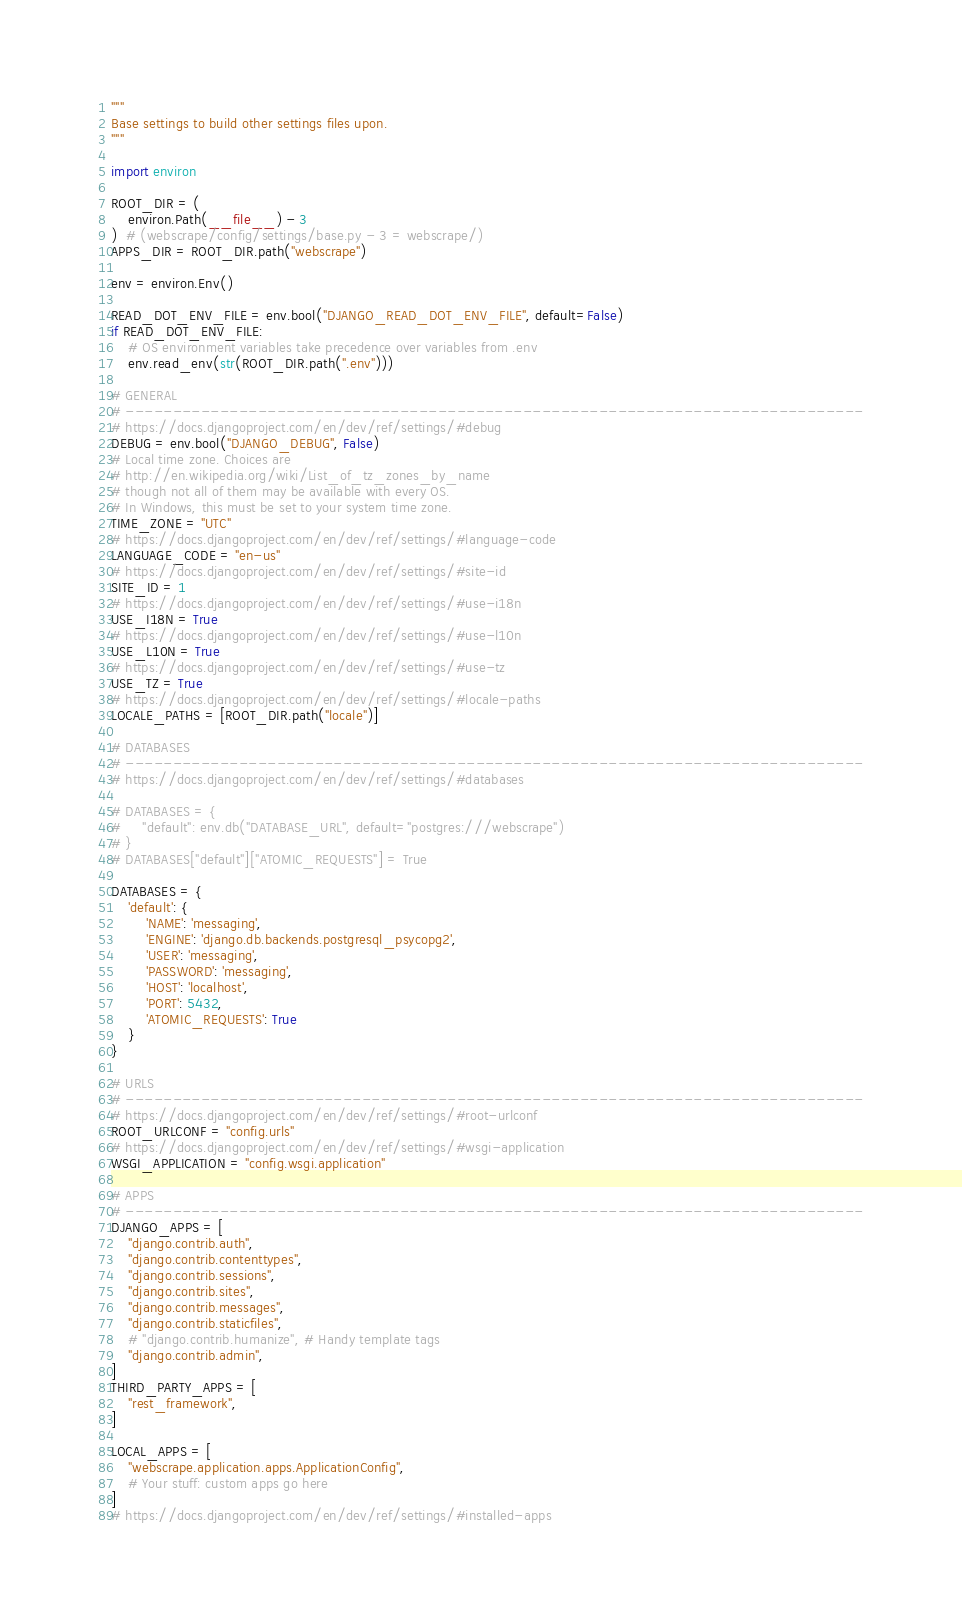Convert code to text. <code><loc_0><loc_0><loc_500><loc_500><_Python_>"""
Base settings to build other settings files upon.
"""

import environ

ROOT_DIR = (
    environ.Path(__file__) - 3
)  # (webscrape/config/settings/base.py - 3 = webscrape/)
APPS_DIR = ROOT_DIR.path("webscrape")

env = environ.Env()

READ_DOT_ENV_FILE = env.bool("DJANGO_READ_DOT_ENV_FILE", default=False)
if READ_DOT_ENV_FILE:
    # OS environment variables take precedence over variables from .env
    env.read_env(str(ROOT_DIR.path(".env")))

# GENERAL
# ------------------------------------------------------------------------------
# https://docs.djangoproject.com/en/dev/ref/settings/#debug
DEBUG = env.bool("DJANGO_DEBUG", False)
# Local time zone. Choices are
# http://en.wikipedia.org/wiki/List_of_tz_zones_by_name
# though not all of them may be available with every OS.
# In Windows, this must be set to your system time zone.
TIME_ZONE = "UTC"
# https://docs.djangoproject.com/en/dev/ref/settings/#language-code
LANGUAGE_CODE = "en-us"
# https://docs.djangoproject.com/en/dev/ref/settings/#site-id
SITE_ID = 1
# https://docs.djangoproject.com/en/dev/ref/settings/#use-i18n
USE_I18N = True
# https://docs.djangoproject.com/en/dev/ref/settings/#use-l10n
USE_L10N = True
# https://docs.djangoproject.com/en/dev/ref/settings/#use-tz
USE_TZ = True
# https://docs.djangoproject.com/en/dev/ref/settings/#locale-paths
LOCALE_PATHS = [ROOT_DIR.path("locale")]

# DATABASES
# ------------------------------------------------------------------------------
# https://docs.djangoproject.com/en/dev/ref/settings/#databases

# DATABASES = {
#     "default": env.db("DATABASE_URL", default="postgres:///webscrape")
# }
# DATABASES["default"]["ATOMIC_REQUESTS"] = True

DATABASES = {
    'default': {
        'NAME': 'messaging',
        'ENGINE': 'django.db.backends.postgresql_psycopg2',
        'USER': 'messaging',
        'PASSWORD': 'messaging',
        'HOST': 'localhost',
        'PORT': 5432,
        'ATOMIC_REQUESTS': True
    }
}

# URLS
# ------------------------------------------------------------------------------
# https://docs.djangoproject.com/en/dev/ref/settings/#root-urlconf
ROOT_URLCONF = "config.urls"
# https://docs.djangoproject.com/en/dev/ref/settings/#wsgi-application
WSGI_APPLICATION = "config.wsgi.application"

# APPS
# ------------------------------------------------------------------------------
DJANGO_APPS = [
    "django.contrib.auth",
    "django.contrib.contenttypes",
    "django.contrib.sessions",
    "django.contrib.sites",
    "django.contrib.messages",
    "django.contrib.staticfiles",
    # "django.contrib.humanize", # Handy template tags
    "django.contrib.admin",
]
THIRD_PARTY_APPS = [
    "rest_framework",
]

LOCAL_APPS = [
    "webscrape.application.apps.ApplicationConfig",
    # Your stuff: custom apps go here
]
# https://docs.djangoproject.com/en/dev/ref/settings/#installed-apps</code> 